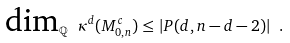Convert formula to latex. <formula><loc_0><loc_0><loc_500><loc_500>\text {dim} _ { \mathbb { Q } } \ \kappa ^ { d } ( M _ { 0 , n } ^ { c } ) \leq | P ( d , n - d - 2 ) | \ .</formula> 